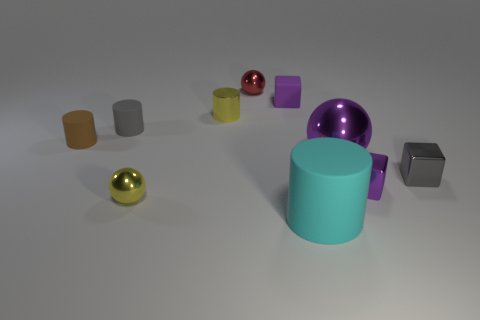Subtract all yellow blocks. Subtract all yellow cylinders. How many blocks are left? 3 Subtract all cylinders. How many objects are left? 6 Add 9 tiny yellow matte cylinders. How many tiny yellow matte cylinders exist? 9 Subtract 1 yellow spheres. How many objects are left? 9 Subtract all small yellow metallic cylinders. Subtract all small blocks. How many objects are left? 6 Add 2 tiny gray things. How many tiny gray things are left? 4 